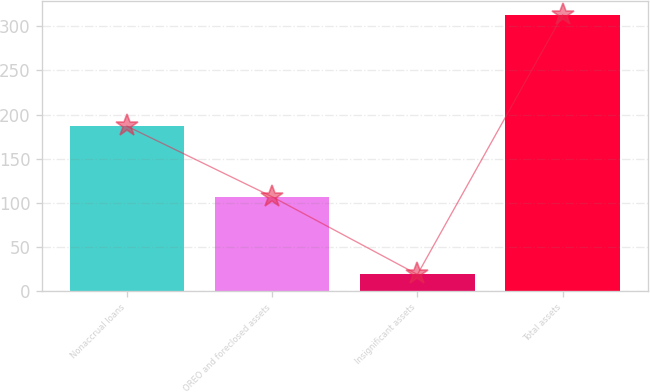<chart> <loc_0><loc_0><loc_500><loc_500><bar_chart><fcel>Nonaccrual loans<fcel>OREO and foreclosed assets<fcel>Insignificant assets<fcel>Total assets<nl><fcel>187<fcel>107<fcel>19<fcel>313<nl></chart> 